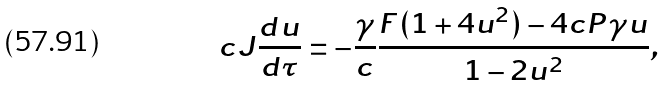Convert formula to latex. <formula><loc_0><loc_0><loc_500><loc_500>c J \frac { d u } { d \tau } = - \frac { \gamma } { c } \frac { F ( 1 + 4 u ^ { 2 } ) - 4 c P \gamma u } { 1 - 2 u ^ { 2 } } ,</formula> 